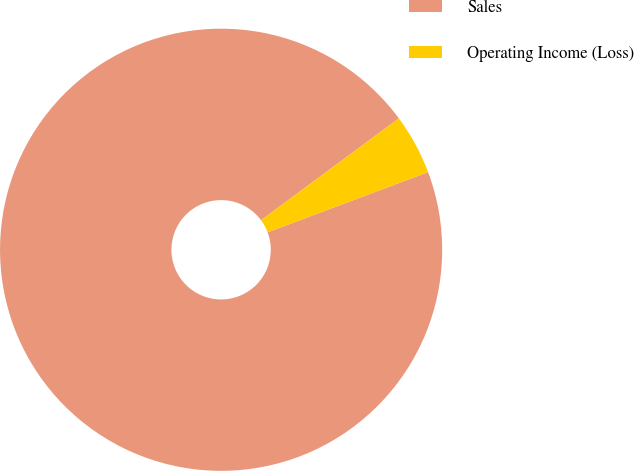Convert chart to OTSL. <chart><loc_0><loc_0><loc_500><loc_500><pie_chart><fcel>Sales<fcel>Operating Income (Loss)<nl><fcel>95.58%<fcel>4.42%<nl></chart> 